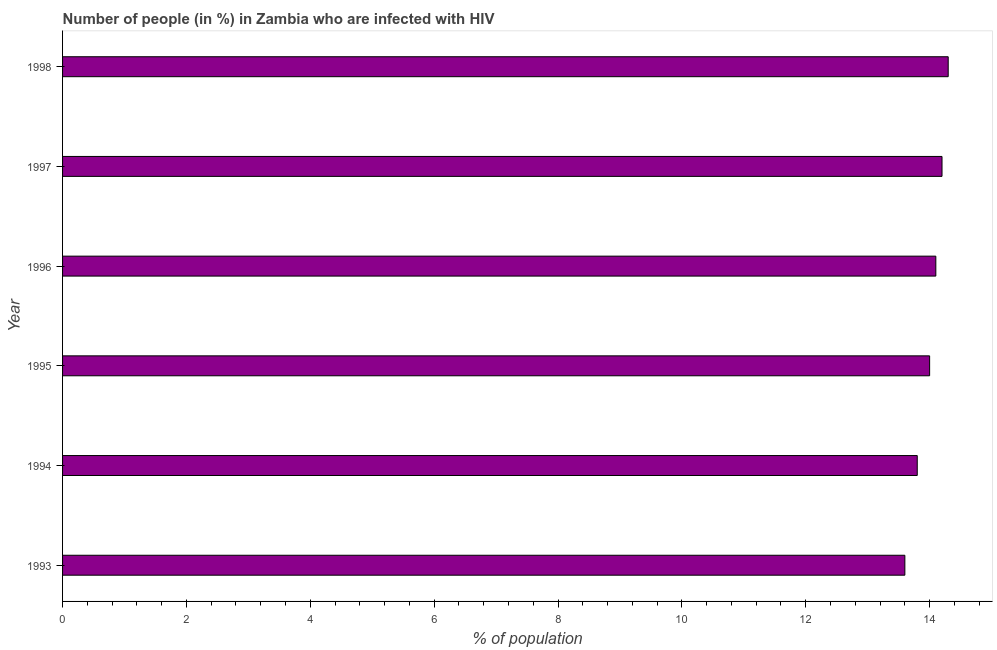Does the graph contain any zero values?
Your answer should be compact. No. Does the graph contain grids?
Your response must be concise. No. What is the title of the graph?
Provide a short and direct response. Number of people (in %) in Zambia who are infected with HIV. What is the label or title of the X-axis?
Ensure brevity in your answer.  % of population. What is the number of people infected with hiv in 1993?
Your response must be concise. 13.6. In which year was the number of people infected with hiv maximum?
Provide a succinct answer. 1998. In which year was the number of people infected with hiv minimum?
Ensure brevity in your answer.  1993. What is the median number of people infected with hiv?
Offer a very short reply. 14.05. Do a majority of the years between 1993 and 1994 (inclusive) have number of people infected with hiv greater than 10.8 %?
Your answer should be compact. Yes. What is the ratio of the number of people infected with hiv in 1993 to that in 1998?
Give a very brief answer. 0.95. Is the number of people infected with hiv in 1996 less than that in 1997?
Offer a very short reply. Yes. Is the difference between the number of people infected with hiv in 1994 and 1997 greater than the difference between any two years?
Ensure brevity in your answer.  No. How many bars are there?
Offer a very short reply. 6. How many years are there in the graph?
Provide a succinct answer. 6. What is the % of population of 1993?
Your answer should be very brief. 13.6. What is the % of population in 1994?
Offer a terse response. 13.8. What is the % of population in 1995?
Ensure brevity in your answer.  14. What is the % of population of 1997?
Offer a terse response. 14.2. What is the difference between the % of population in 1993 and 1997?
Your answer should be compact. -0.6. What is the difference between the % of population in 1994 and 1995?
Make the answer very short. -0.2. What is the difference between the % of population in 1994 and 1996?
Ensure brevity in your answer.  -0.3. What is the difference between the % of population in 1994 and 1997?
Provide a short and direct response. -0.4. What is the difference between the % of population in 1994 and 1998?
Your answer should be very brief. -0.5. What is the difference between the % of population in 1995 and 1996?
Keep it short and to the point. -0.1. What is the difference between the % of population in 1996 and 1997?
Provide a succinct answer. -0.1. What is the difference between the % of population in 1996 and 1998?
Your response must be concise. -0.2. What is the difference between the % of population in 1997 and 1998?
Your answer should be compact. -0.1. What is the ratio of the % of population in 1993 to that in 1996?
Offer a very short reply. 0.96. What is the ratio of the % of population in 1993 to that in 1997?
Your answer should be compact. 0.96. What is the ratio of the % of population in 1993 to that in 1998?
Your answer should be very brief. 0.95. What is the ratio of the % of population in 1994 to that in 1996?
Your response must be concise. 0.98. What is the ratio of the % of population in 1994 to that in 1997?
Offer a very short reply. 0.97. What is the ratio of the % of population in 1995 to that in 1996?
Ensure brevity in your answer.  0.99. What is the ratio of the % of population in 1995 to that in 1997?
Offer a terse response. 0.99. 